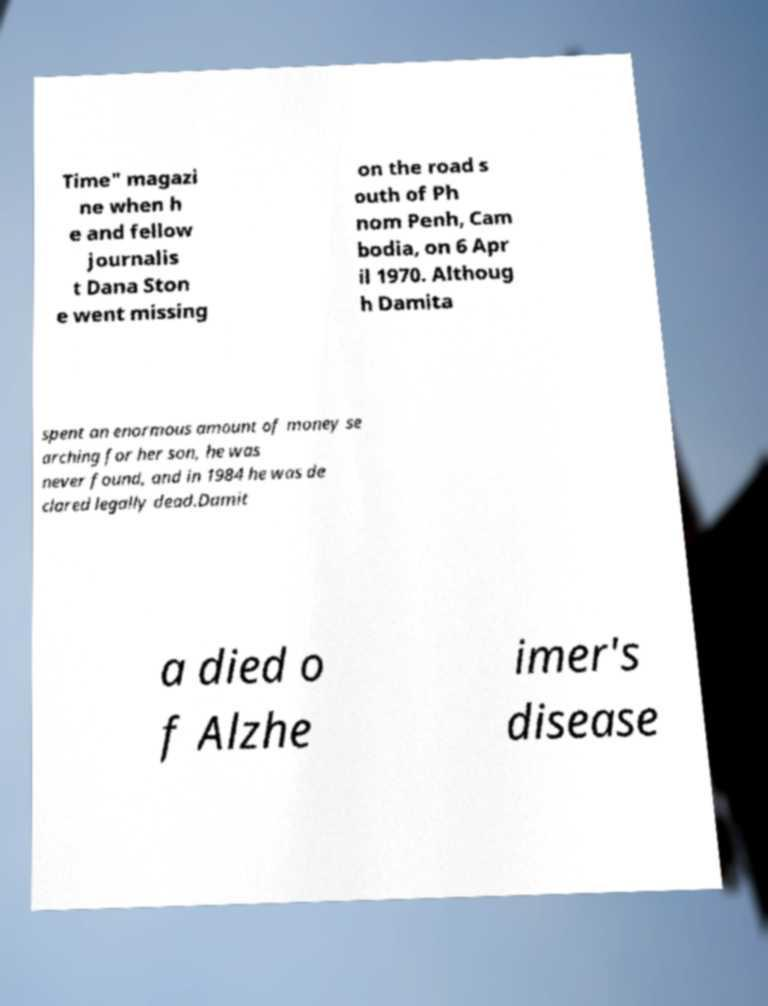There's text embedded in this image that I need extracted. Can you transcribe it verbatim? Time" magazi ne when h e and fellow journalis t Dana Ston e went missing on the road s outh of Ph nom Penh, Cam bodia, on 6 Apr il 1970. Althoug h Damita spent an enormous amount of money se arching for her son, he was never found, and in 1984 he was de clared legally dead.Damit a died o f Alzhe imer's disease 